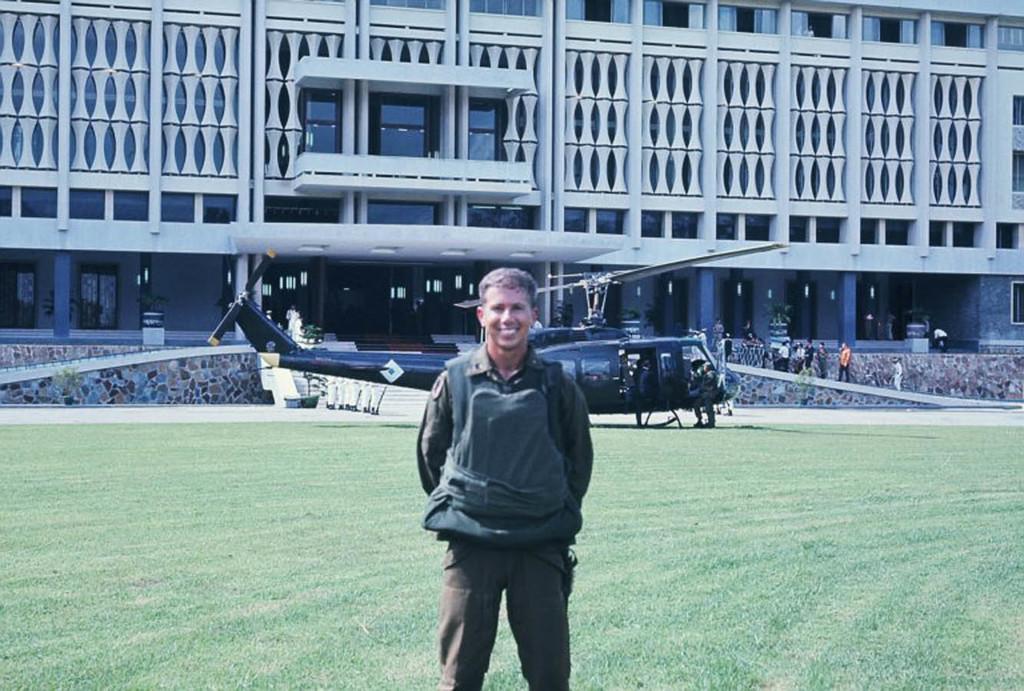How would you summarize this image in a sentence or two? This picture describes about group of people, in the middle of the image we can see a man, he is standing on the grass and he is smiling, in the background we can see a helicopter and a building. 